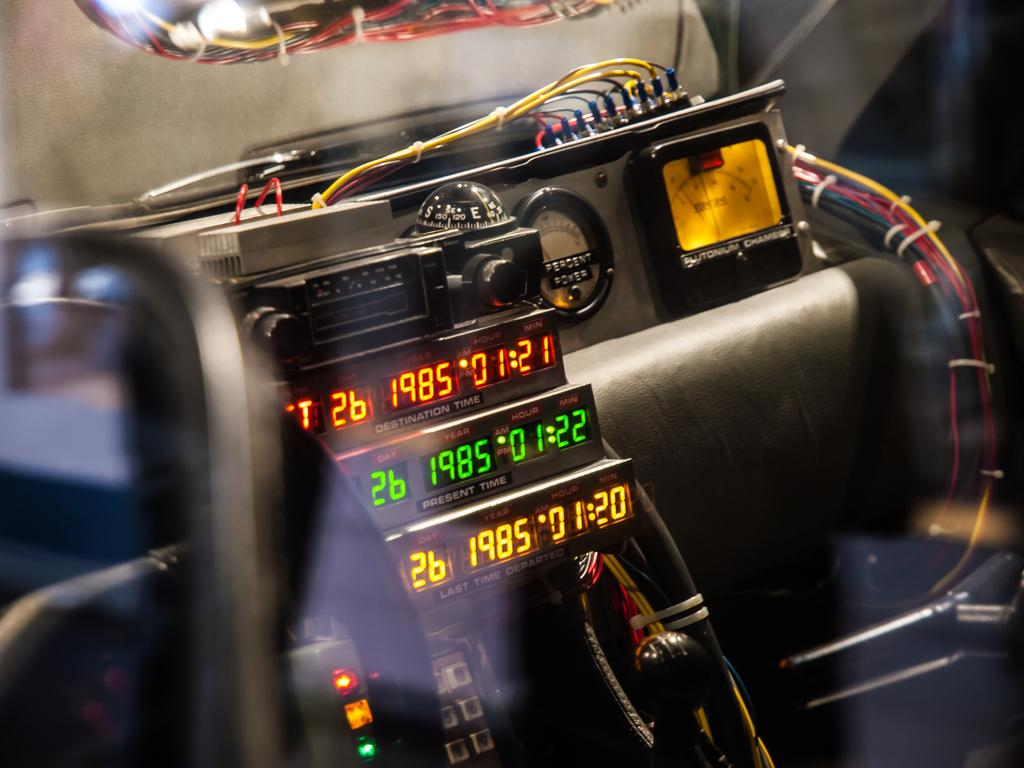What is the main object in the image? There is a machine in the image. What is the machine displaying? The machine is displaying time instances. How are the time instances connected to the machine? There are many wires connected to the machine. How many bears can be seen playing with a card in the image? There are no bears or cards present in the image. 